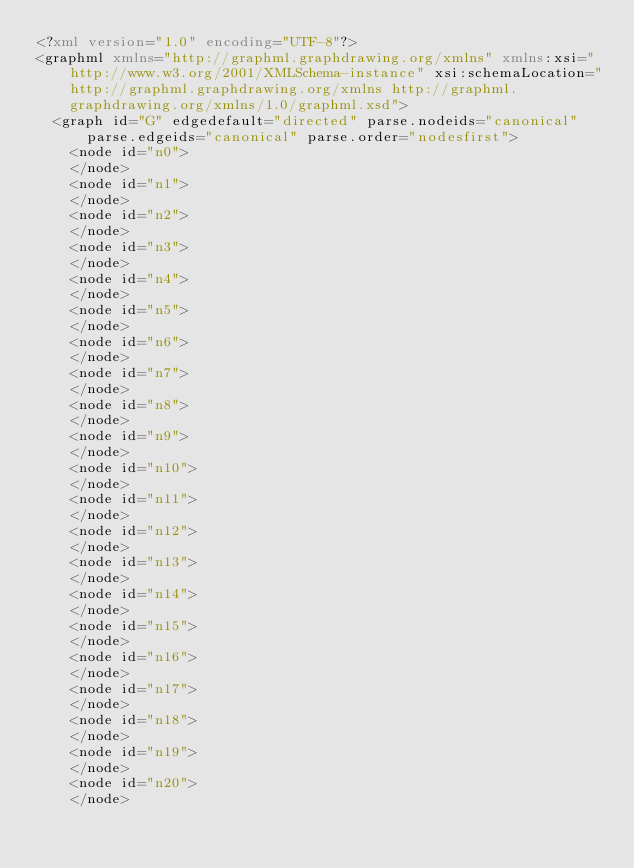<code> <loc_0><loc_0><loc_500><loc_500><_XML_><?xml version="1.0" encoding="UTF-8"?>
<graphml xmlns="http://graphml.graphdrawing.org/xmlns" xmlns:xsi="http://www.w3.org/2001/XMLSchema-instance" xsi:schemaLocation="http://graphml.graphdrawing.org/xmlns http://graphml.graphdrawing.org/xmlns/1.0/graphml.xsd">
  <graph id="G" edgedefault="directed" parse.nodeids="canonical" parse.edgeids="canonical" parse.order="nodesfirst">
    <node id="n0">
    </node>
    <node id="n1">
    </node>
    <node id="n2">
    </node>
    <node id="n3">
    </node>
    <node id="n4">
    </node>
    <node id="n5">
    </node>
    <node id="n6">
    </node>
    <node id="n7">
    </node>
    <node id="n8">
    </node>
    <node id="n9">
    </node>
    <node id="n10">
    </node>
    <node id="n11">
    </node>
    <node id="n12">
    </node>
    <node id="n13">
    </node>
    <node id="n14">
    </node>
    <node id="n15">
    </node>
    <node id="n16">
    </node>
    <node id="n17">
    </node>
    <node id="n18">
    </node>
    <node id="n19">
    </node>
    <node id="n20">
    </node></code> 